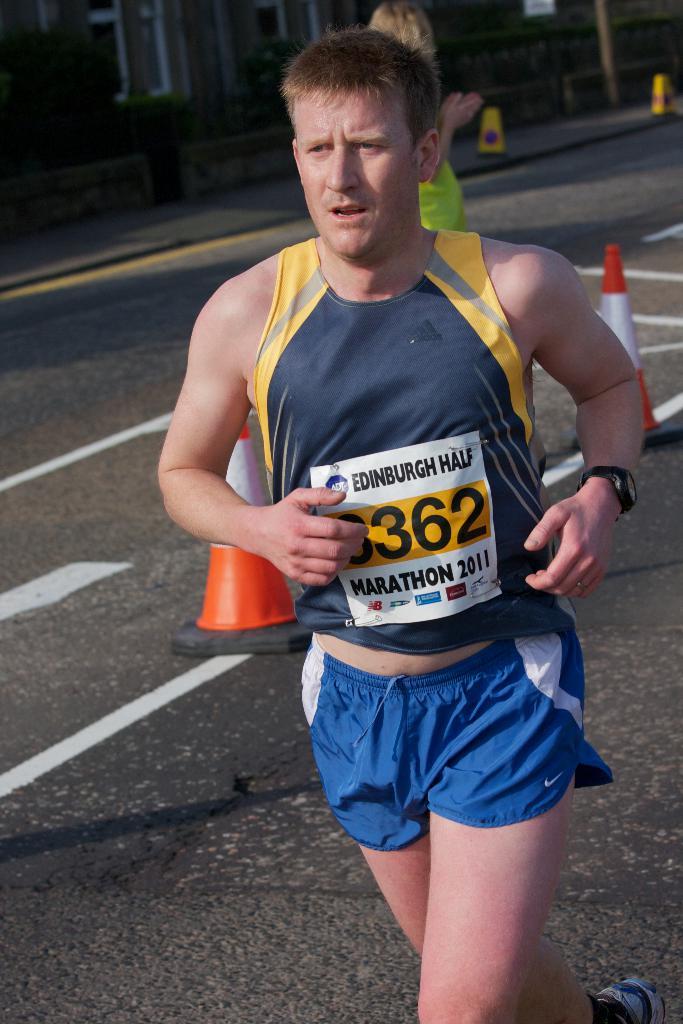What is the runners number?
Your answer should be very brief. 3362. What color are the runners shorts?
Offer a very short reply. Answering does not require reading text in the image. 